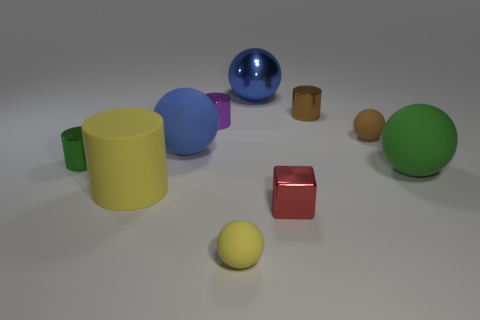Subtract all small spheres. How many spheres are left? 3 Subtract all cubes. How many objects are left? 9 Subtract all small cylinders. Subtract all tiny purple cylinders. How many objects are left? 6 Add 8 small brown metal things. How many small brown metal things are left? 9 Add 7 large cyan metallic objects. How many large cyan metallic objects exist? 7 Subtract all blue spheres. How many spheres are left? 3 Subtract 1 brown cylinders. How many objects are left? 9 Subtract 1 cubes. How many cubes are left? 0 Subtract all yellow spheres. Subtract all cyan blocks. How many spheres are left? 4 Subtract all red spheres. How many green cylinders are left? 1 